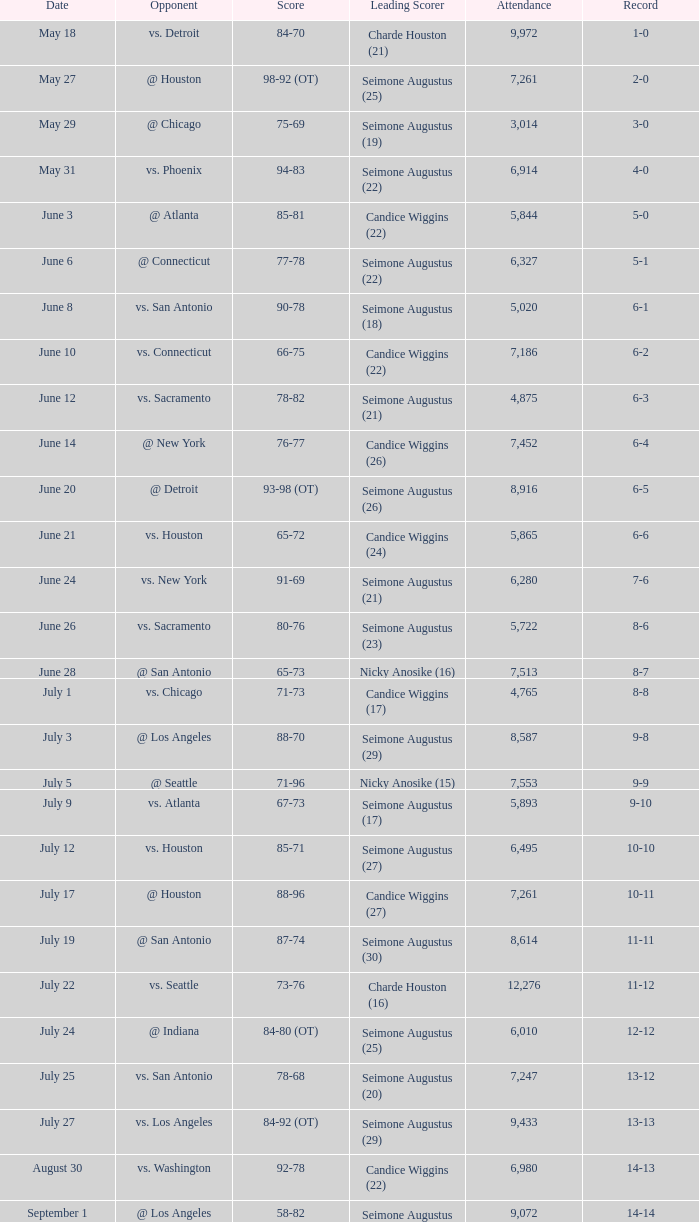Which Score has an Opponent of @ houston, and a Record of 2-0? 98-92 (OT). 